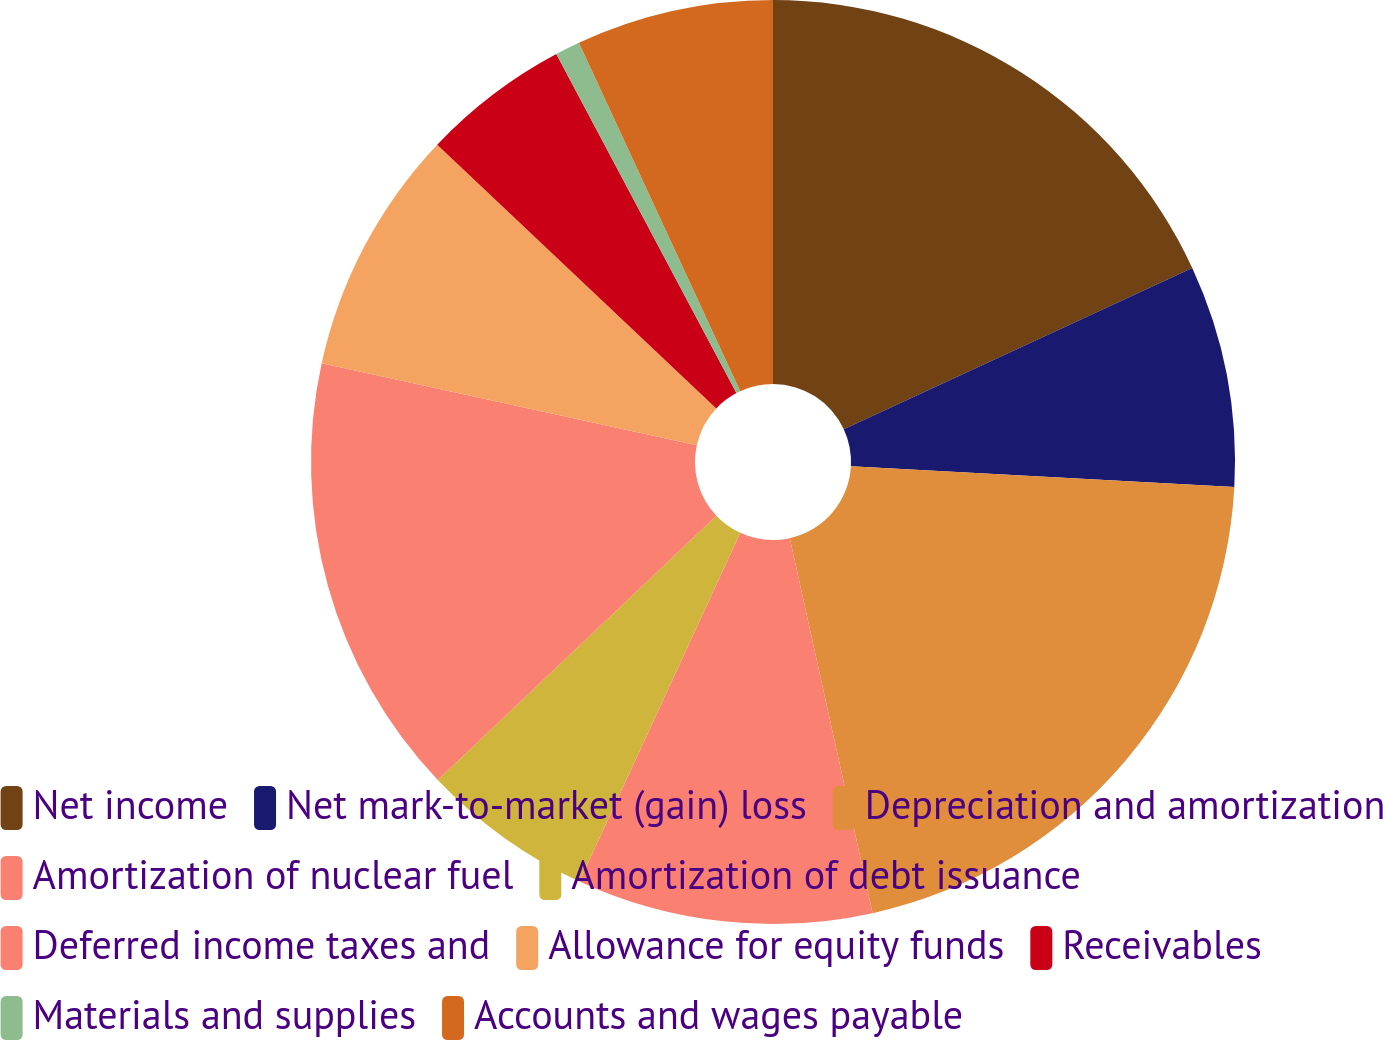<chart> <loc_0><loc_0><loc_500><loc_500><pie_chart><fcel>Net income<fcel>Net mark-to-market (gain) loss<fcel>Depreciation and amortization<fcel>Amortization of nuclear fuel<fcel>Amortization of debt issuance<fcel>Deferred income taxes and<fcel>Allowance for equity funds<fcel>Receivables<fcel>Materials and supplies<fcel>Accounts and wages payable<nl><fcel>18.1%<fcel>7.76%<fcel>20.68%<fcel>10.34%<fcel>6.04%<fcel>15.51%<fcel>8.62%<fcel>5.18%<fcel>0.87%<fcel>6.9%<nl></chart> 